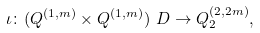<formula> <loc_0><loc_0><loc_500><loc_500>\iota \colon ( Q ^ { ( 1 , m ) } \times Q ^ { ( 1 , m ) } ) \ D \to Q _ { 2 } ^ { ( 2 , 2 m ) } ,</formula> 